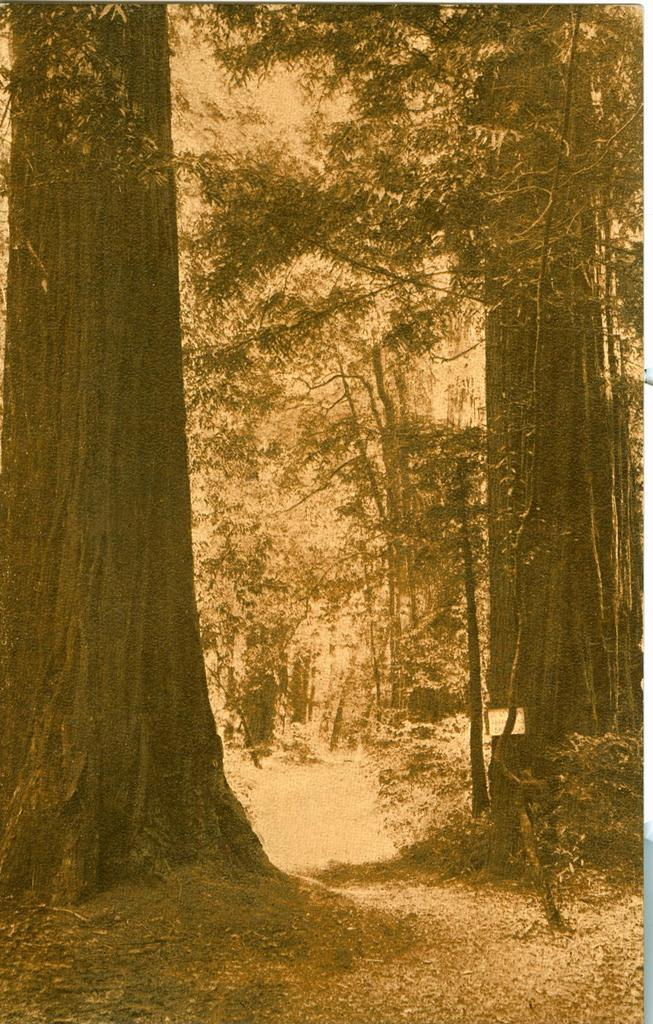What type of vegetation can be seen in the image? There are trees and plants in the image. Can you describe the terrain visible in the image? There is land visible at the bottom of the image. What is the behavior of the trees in the image? The trees in the image do not exhibit any behavior, as they are stationary objects. 